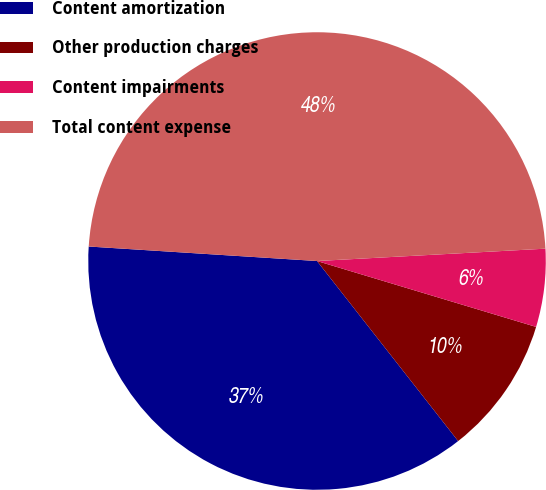Convert chart to OTSL. <chart><loc_0><loc_0><loc_500><loc_500><pie_chart><fcel>Content amortization<fcel>Other production charges<fcel>Content impairments<fcel>Total content expense<nl><fcel>36.59%<fcel>9.77%<fcel>5.51%<fcel>48.13%<nl></chart> 